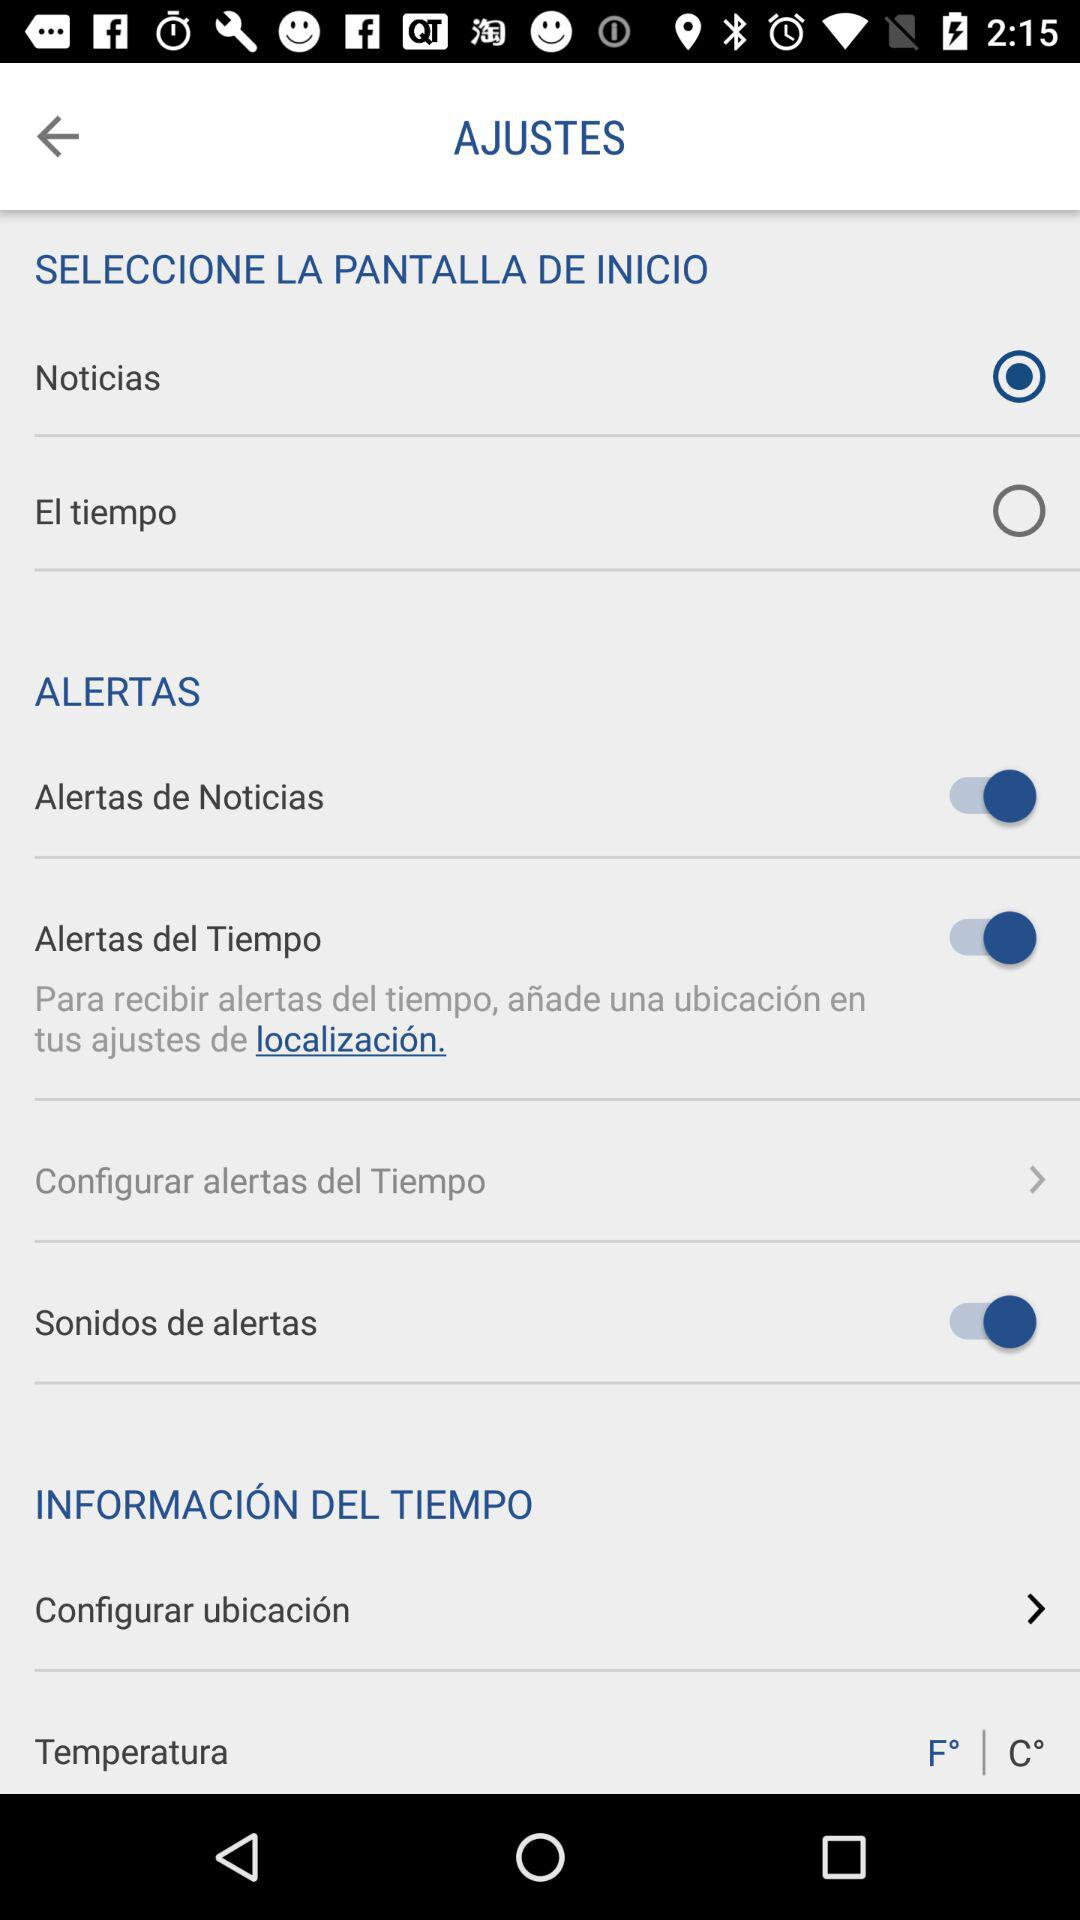Which option was selected? The selected option was "Noticias". 